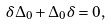<formula> <loc_0><loc_0><loc_500><loc_500>\delta \Delta _ { 0 } + \Delta _ { 0 } \delta = 0 ,</formula> 